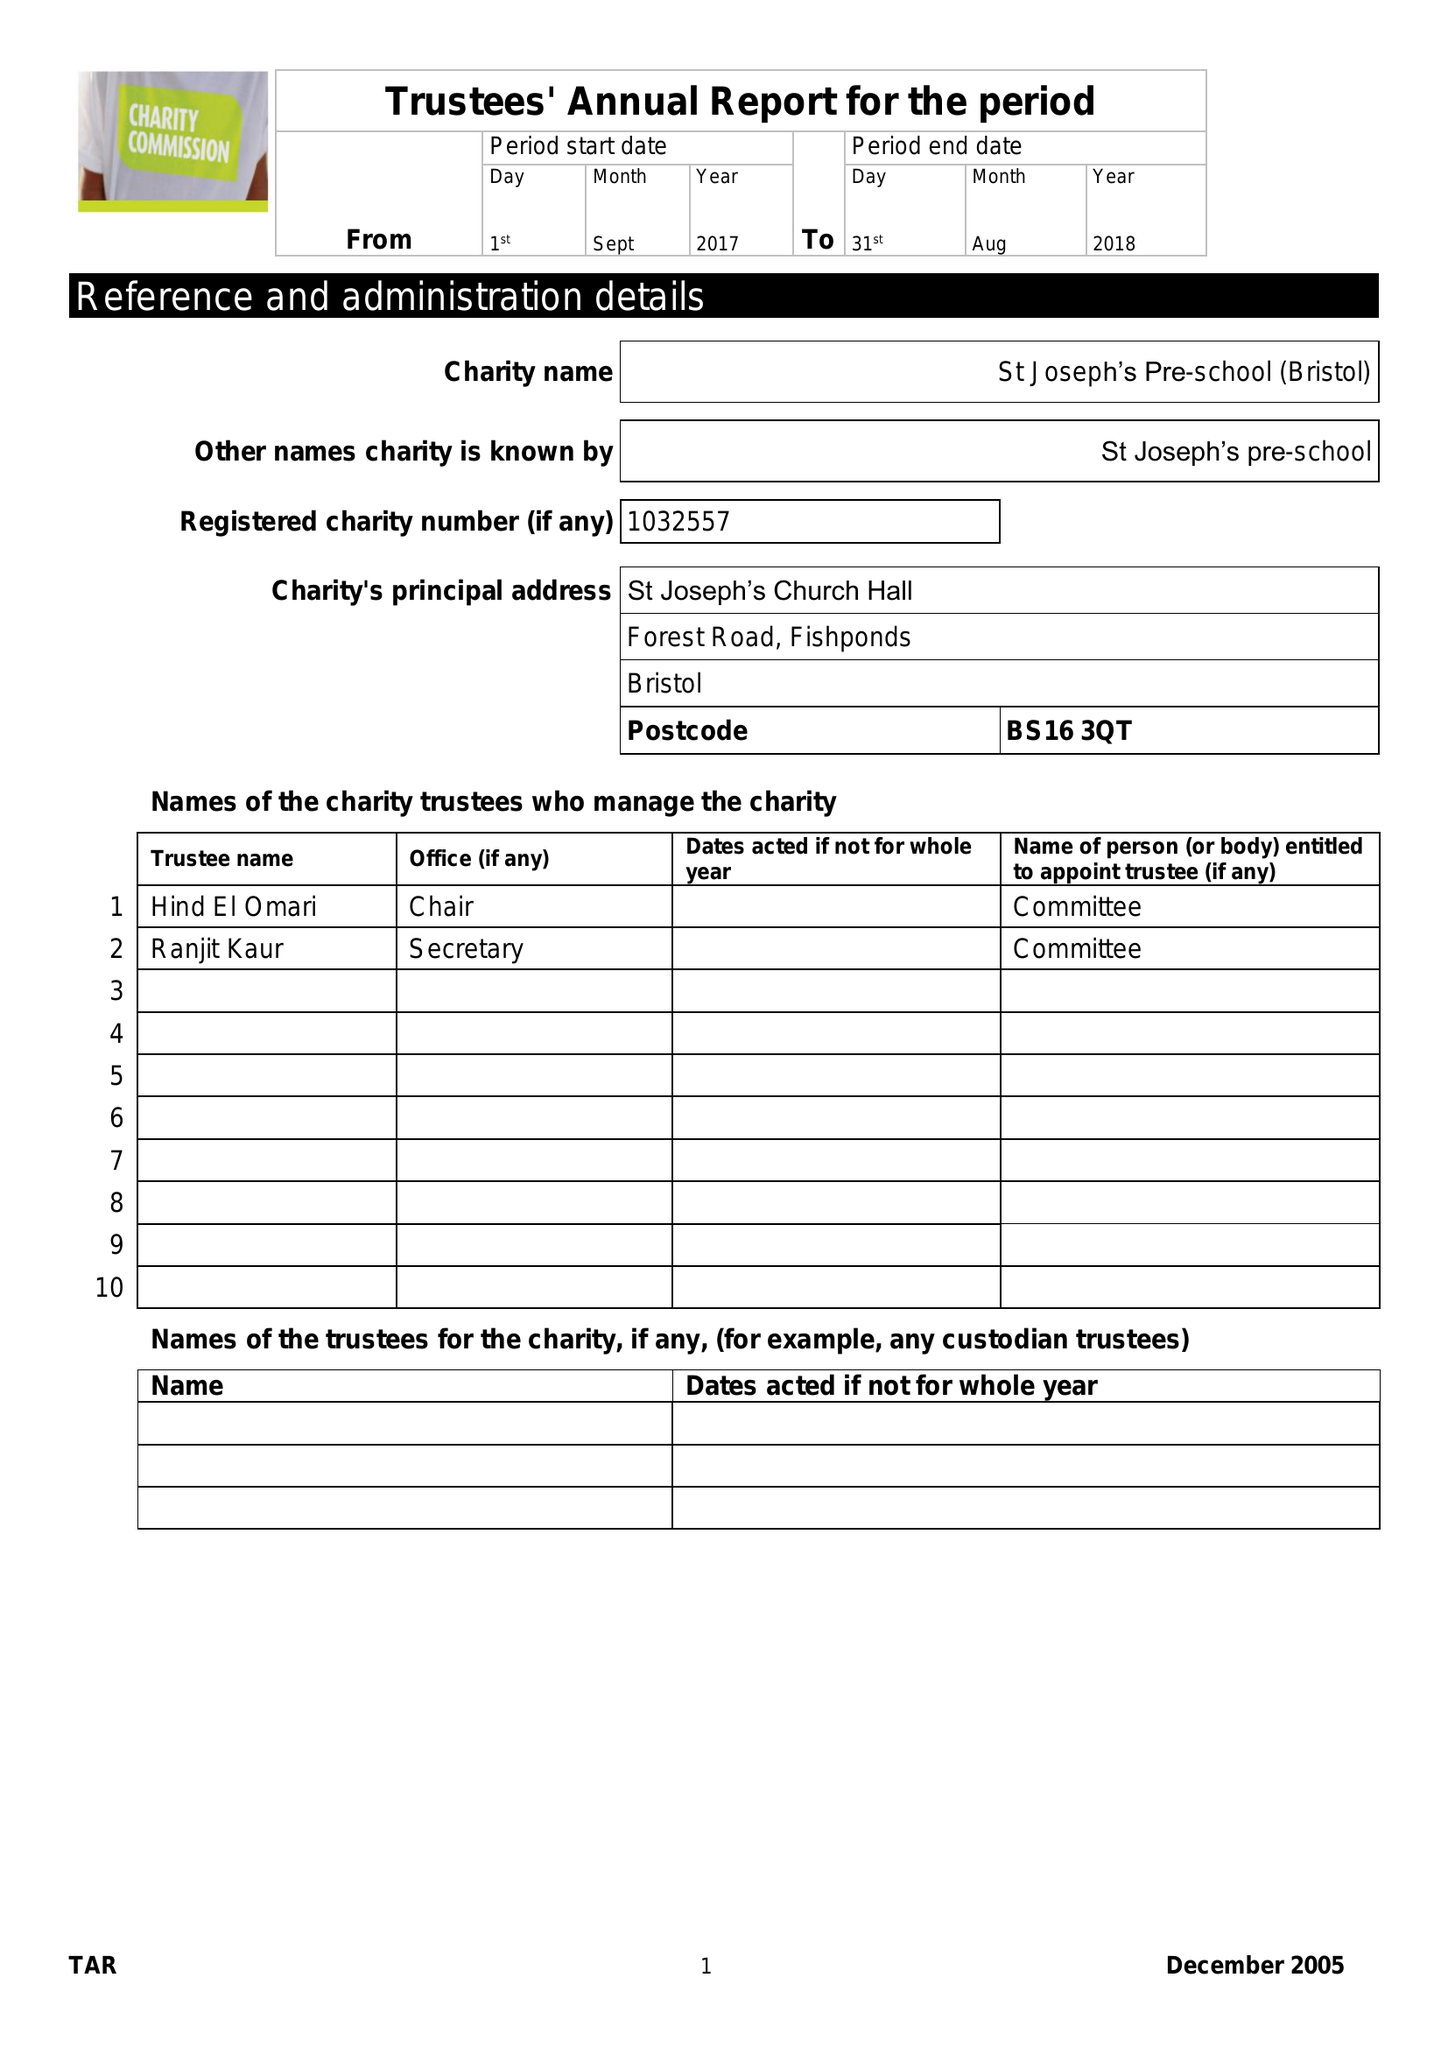What is the value for the charity_number?
Answer the question using a single word or phrase. 1032557 